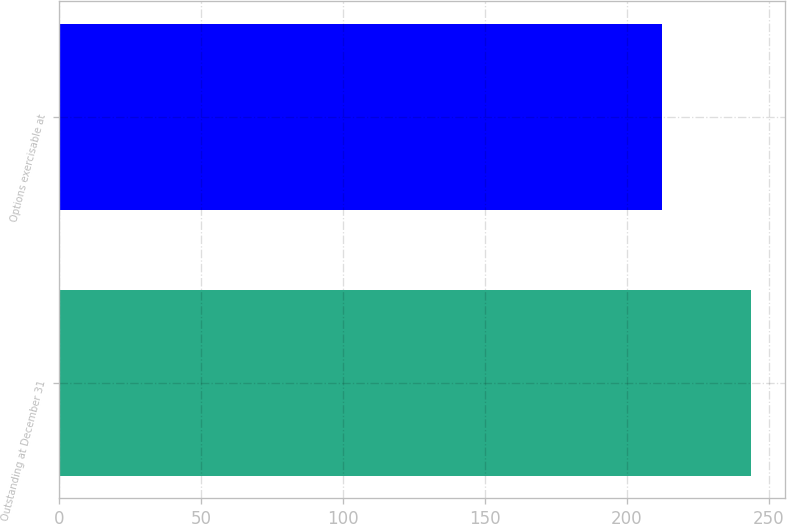<chart> <loc_0><loc_0><loc_500><loc_500><bar_chart><fcel>Outstanding at December 31<fcel>Options exercisable at<nl><fcel>243.7<fcel>212.38<nl></chart> 